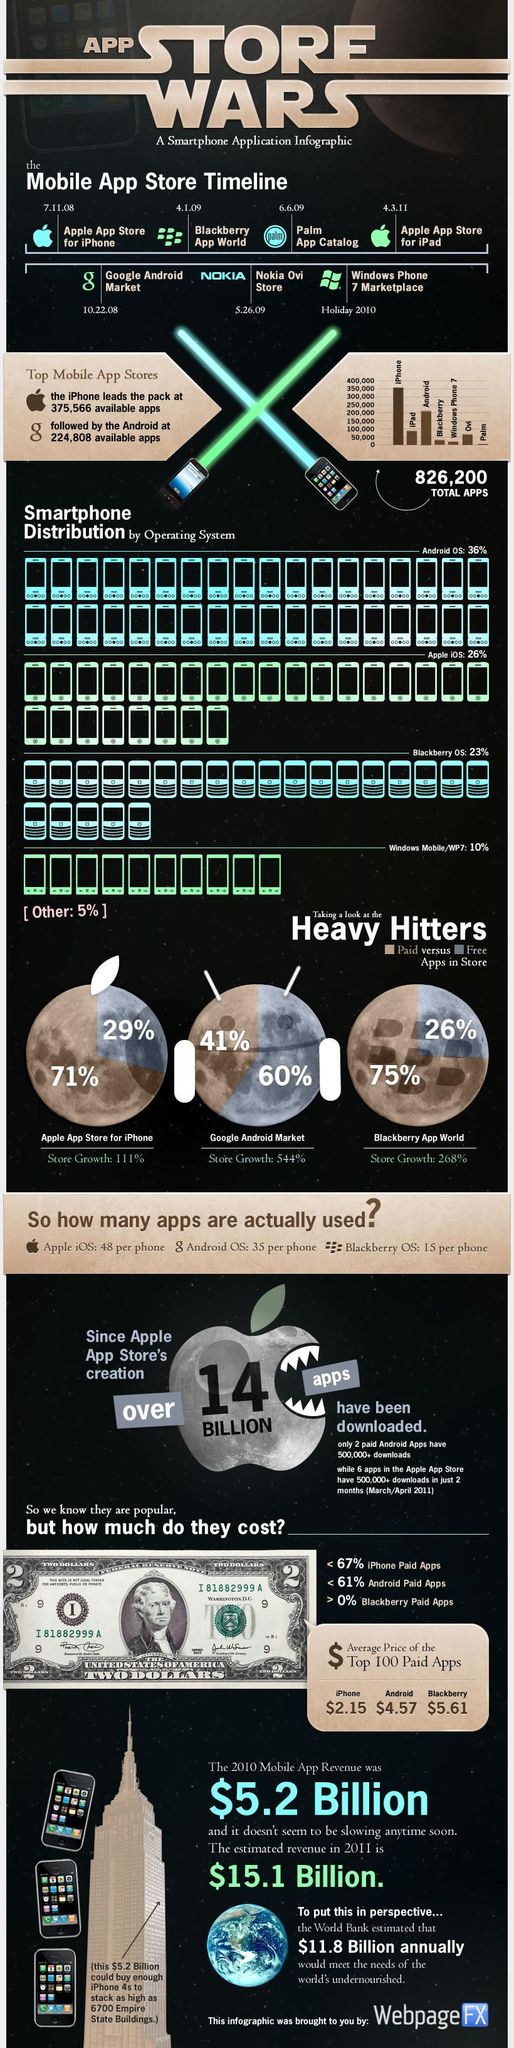Highlight a few significant elements in this photo. The percentage store growth of Android and Blackberry is different. The percentage store growth of Android is 276%. There is a discrepancy in the percentage of paid apps on both the iPhone and Android stores, with the combined total being higher than 100%. According to data, 89% of apps in the combined iPhone and Android stores are free. The percentage store growth of Android is 433%. The combined distribution of Android OS and Apple IOS is 62%. 